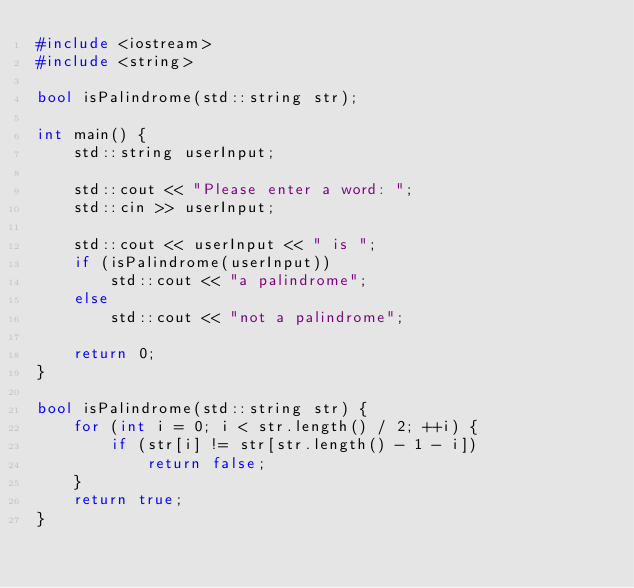Convert code to text. <code><loc_0><loc_0><loc_500><loc_500><_C++_>#include <iostream>
#include <string>

bool isPalindrome(std::string str);

int main() {
	std::string userInput;

	std::cout << "Please enter a word: ";
	std::cin >> userInput;
	
	std::cout << userInput << " is ";
	if (isPalindrome(userInput))
		std::cout << "a palindrome";
	else
		std::cout << "not a palindrome";

	return 0;
}

bool isPalindrome(std::string str) {
	for (int i = 0; i < str.length() / 2; ++i) {
		if (str[i] != str[str.length() - 1 - i])
			return false;
	}
	return true;
}</code> 